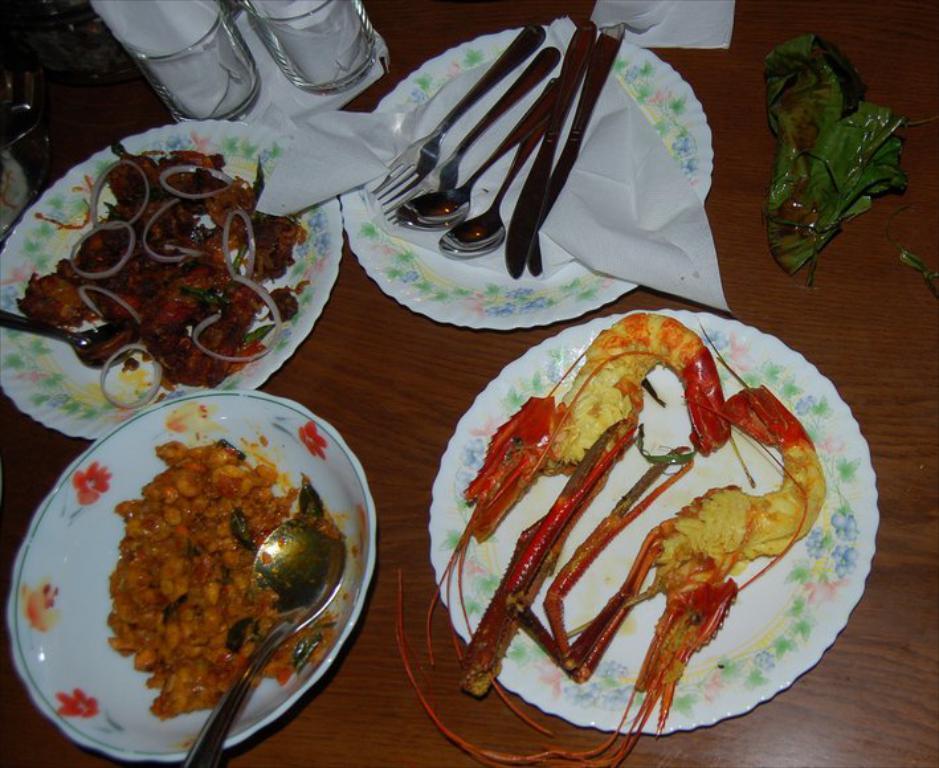Can you describe this image briefly? In this image, we can see the wooden surface. We can see some plates with food items and spoons. We can also see some glasses, tissues and green colored objects. We can also see some glass objects on the top left corner. 